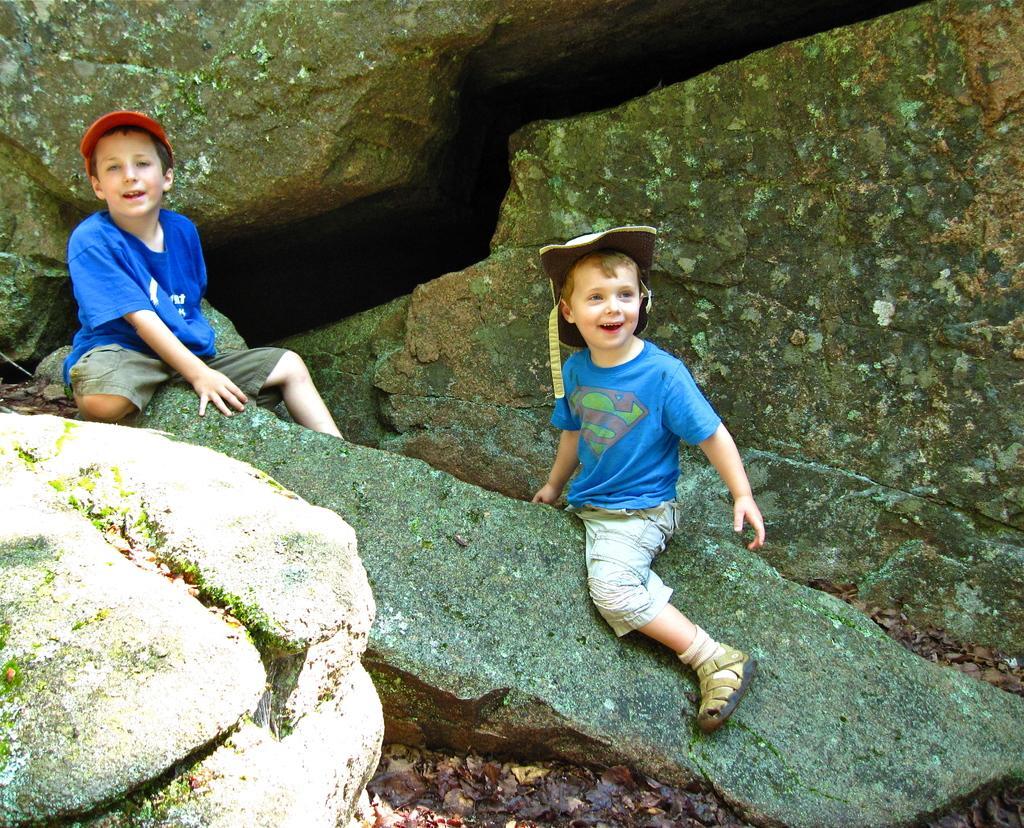Could you give a brief overview of what you see in this image? Here I can see two boys wearing blue color t-shirts, caps on the heads, sitting on a rock and smiling. At the bottom, I can see the ground. In the background there are some more rocks. 